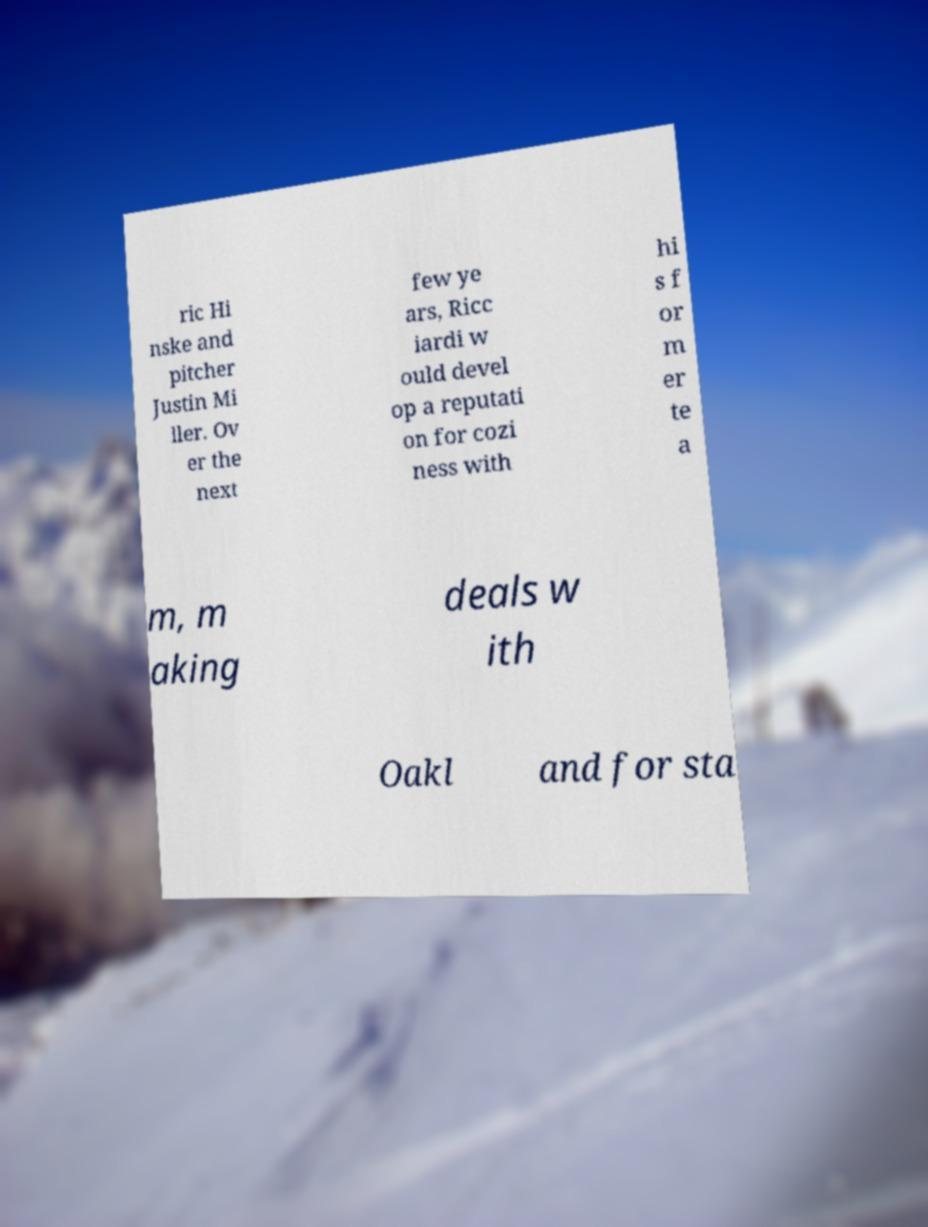Could you extract and type out the text from this image? ric Hi nske and pitcher Justin Mi ller. Ov er the next few ye ars, Ricc iardi w ould devel op a reputati on for cozi ness with hi s f or m er te a m, m aking deals w ith Oakl and for sta 